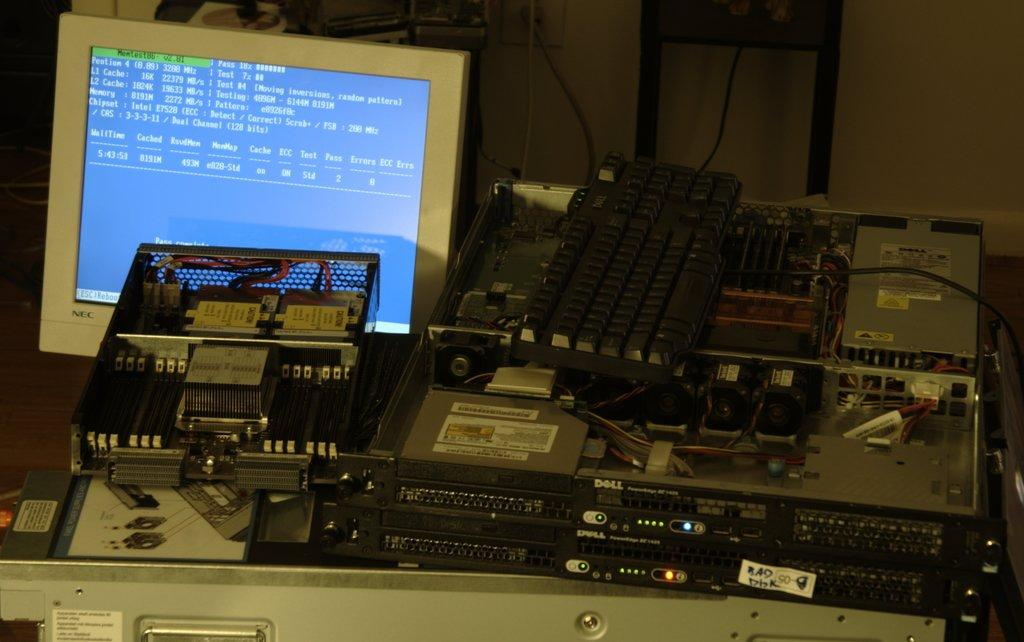What electronic devices are visible in the image? There are sound boxes and a keyboard in the image. What component is present in the image that is related to electrical connections? There is a circuit in the image. What type of computer is on the table in the image? There is a PC on the table in the image. What can be seen in the background of the room? There is a wall, books, and wires in the background of the image. What type of airplane is visible in the image? There is no airplane present in the image; it is taken in a room with electronic devices and a PC on a table. 